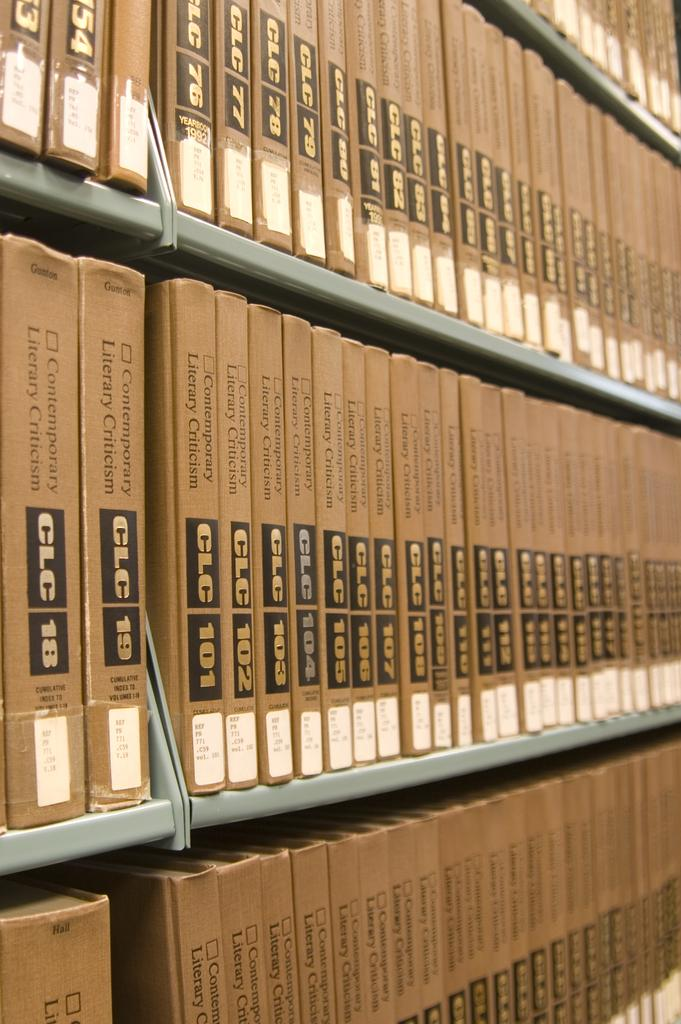What type of items can be seen on the shelves in the image? There are books on the shelves in the image. What is the color of the shelves? The shelves are gray in color. What else can be found on the shelves besides books? There are boxes with text and stickers on the shelves. Can you tell me the title of the book that has a hole in the middle? There is no book with a hole in the middle in the image, so it is not possible to determine its title. 